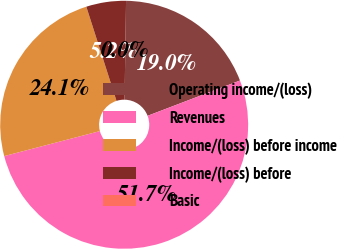Convert chart to OTSL. <chart><loc_0><loc_0><loc_500><loc_500><pie_chart><fcel>Operating income/(loss)<fcel>Revenues<fcel>Income/(loss) before income<fcel>Income/(loss) before<fcel>Basic<nl><fcel>18.95%<fcel>51.74%<fcel>24.13%<fcel>5.18%<fcel>0.0%<nl></chart> 